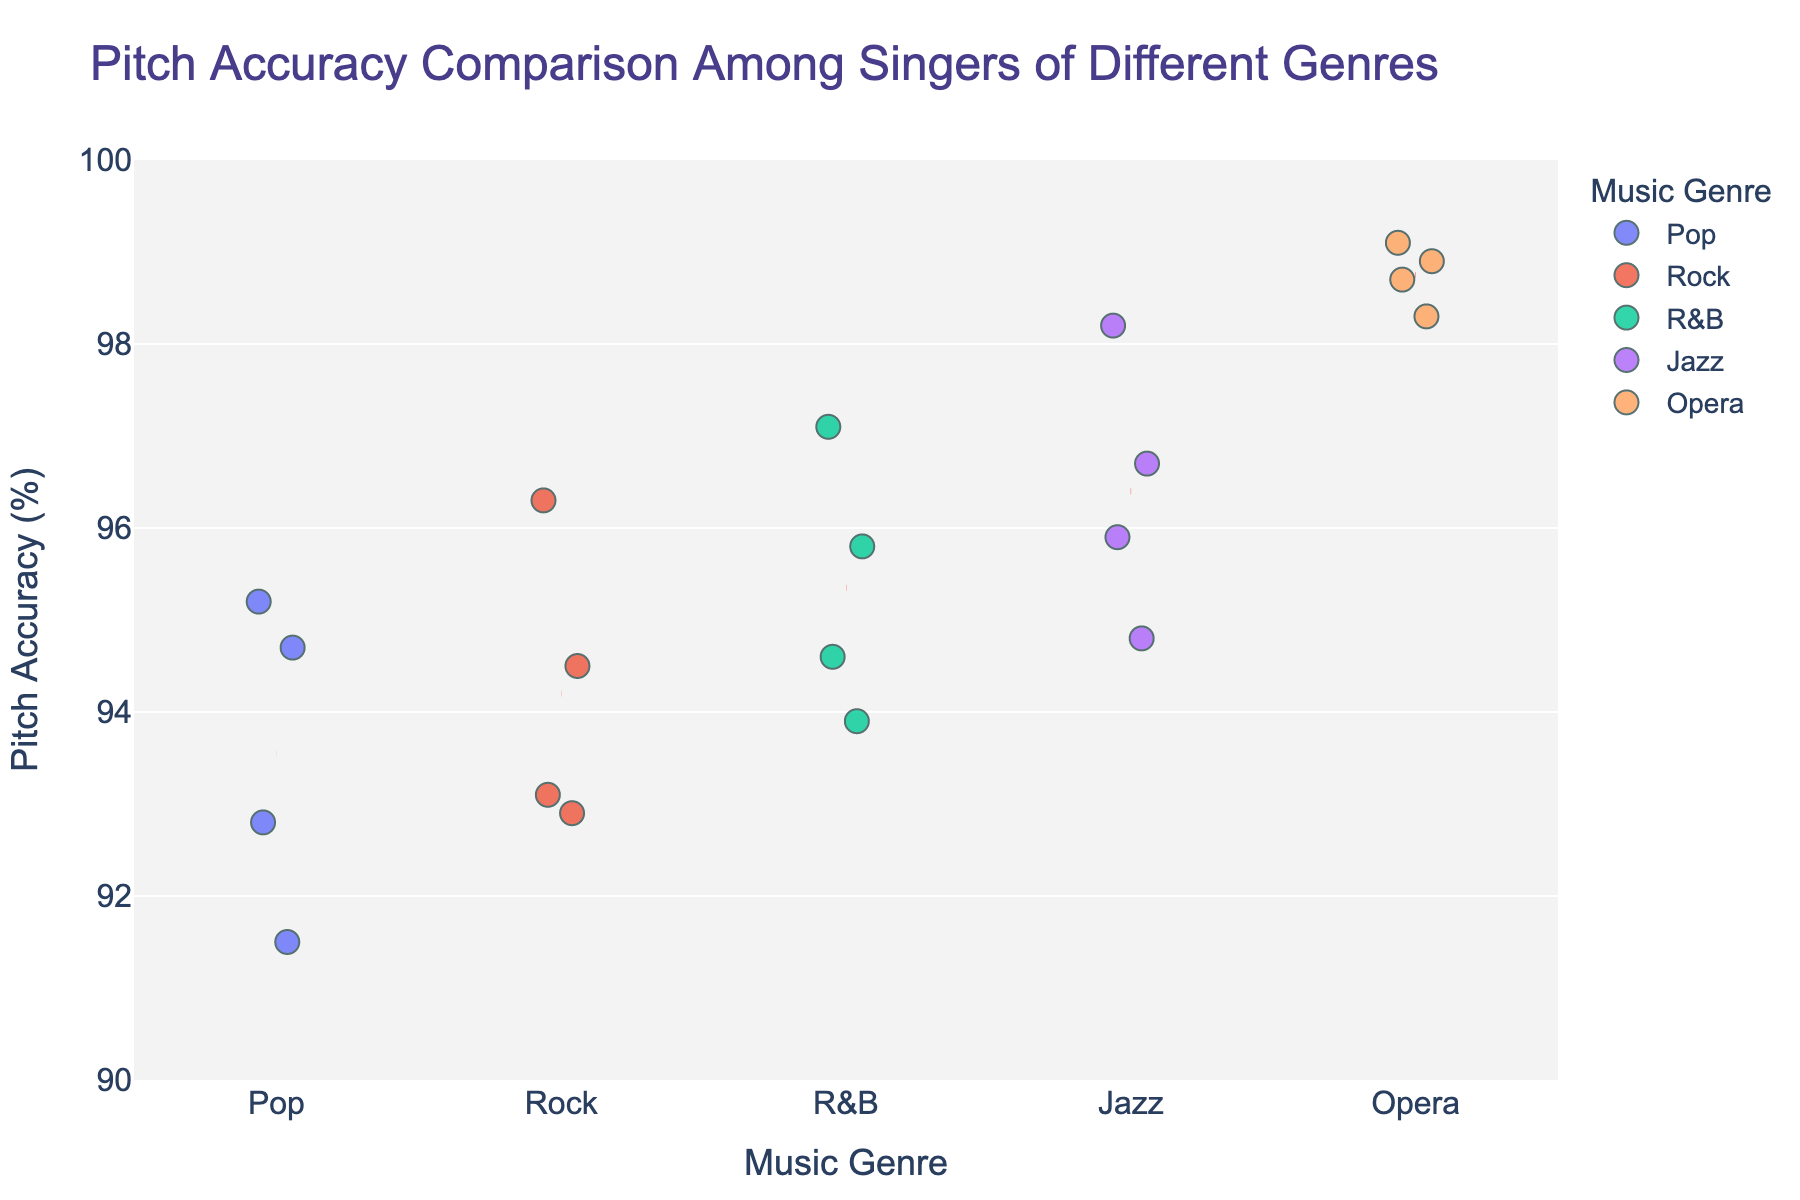What's the title of the figure? The title is usually displayed at the top of the figure and provides a brief description of the plot.
Answer: Pitch Accuracy Comparison Among Singers of Different Genres What are the labels of the x-axis and y-axis? The labels for the axes are typically located near the respective axes, indicating what is being measured or compared. The x-axis label is "Music Genre" and the y-axis label is "Pitch Accuracy (%)".
Answer: Music Genre, Pitch Accuracy (%) Which genre has the highest average pitch accuracy? To find the average pitch accuracy for each genre, I need to look at the red dashed lines representing the mean values. The Opera genre has the highest mean line, indicating the highest average pitch accuracy.
Answer: Opera How many data points are there in the Pop genre? Look at the number of dots in the Pop category or hover over the dots if the figure is interactive. There are four data points for Pop singers.
Answer: 4 Which singer has the highest pitch accuracy, and to which genre do they belong? Identify the highest point on the y-axis and check the corresponding singer and genre. Ella Fitzgerald with a pitch accuracy of 98.2% is the highest in the Jazz genre.
Answer: Ella Fitzgerald, Jazz What's the difference in average pitch accuracy between Jazz and Rock genres? Calculate the mean pitch accuracy for Jazz and Rock by looking at the red dashed lines. Jazz has a mean above 95.65% and Rock around 94.2%. The difference would be approximately 95.65% - 94.2%.
Answer: 1.45% Are there any outliers in the Opera genre? Outliers would appear as singular points far from others on the plot. All point data in Opera is closely packed, indicating no significant outliers.
Answer: No Which genre has the most consistent pitch accuracy, as indicated by the spread of data points? Look at the vertical spread of data points within each genre. Opera shows the least spread, indicating the most consistent pitch accuracy.
Answer: Opera Who has the lowest pitch accuracy among all the singers? Identify the lowest point on the y-axis and check the corresponding data. Ed Sheeran in the Pop genre has the lowest pitch accuracy at 91.5%.
Answer: Ed Sheeran Which genres are represented by only male singers? From the plot, identify the gender of each singer in each genre. Jazz (Tony Bennett, Michael Bublé) and Opera (Luciano Pavarotti, Plácido Domingo) have only male singers.
Answer: Jazz, Opera 